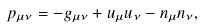Convert formula to latex. <formula><loc_0><loc_0><loc_500><loc_500>p _ { \mu \nu } = - g _ { \mu \nu } + u _ { \mu } u _ { \nu } - n _ { \mu } n _ { \nu } ,</formula> 